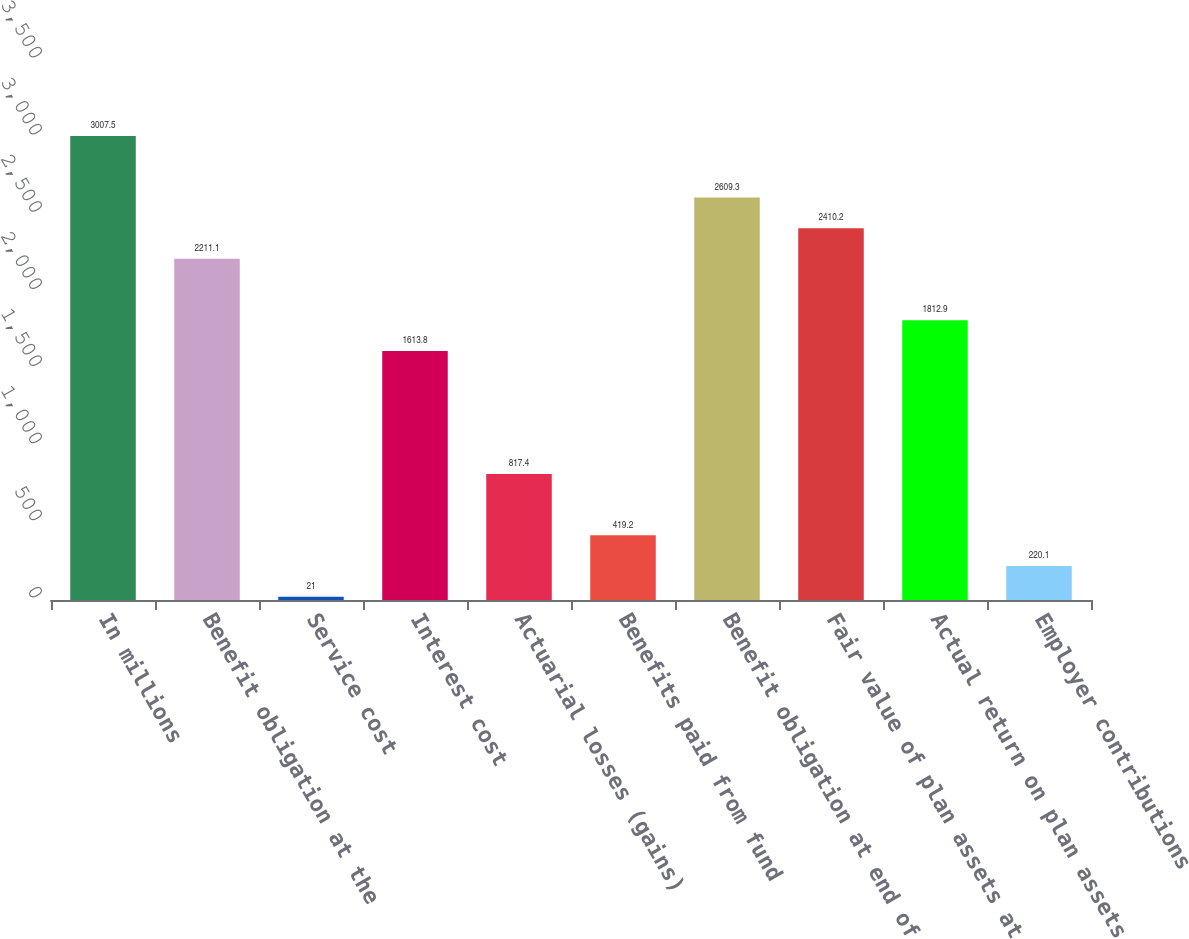Convert chart. <chart><loc_0><loc_0><loc_500><loc_500><bar_chart><fcel>In millions<fcel>Benefit obligation at the<fcel>Service cost<fcel>Interest cost<fcel>Actuarial losses (gains)<fcel>Benefits paid from fund<fcel>Benefit obligation at end of<fcel>Fair value of plan assets at<fcel>Actual return on plan assets<fcel>Employer contributions<nl><fcel>3007.5<fcel>2211.1<fcel>21<fcel>1613.8<fcel>817.4<fcel>419.2<fcel>2609.3<fcel>2410.2<fcel>1812.9<fcel>220.1<nl></chart> 